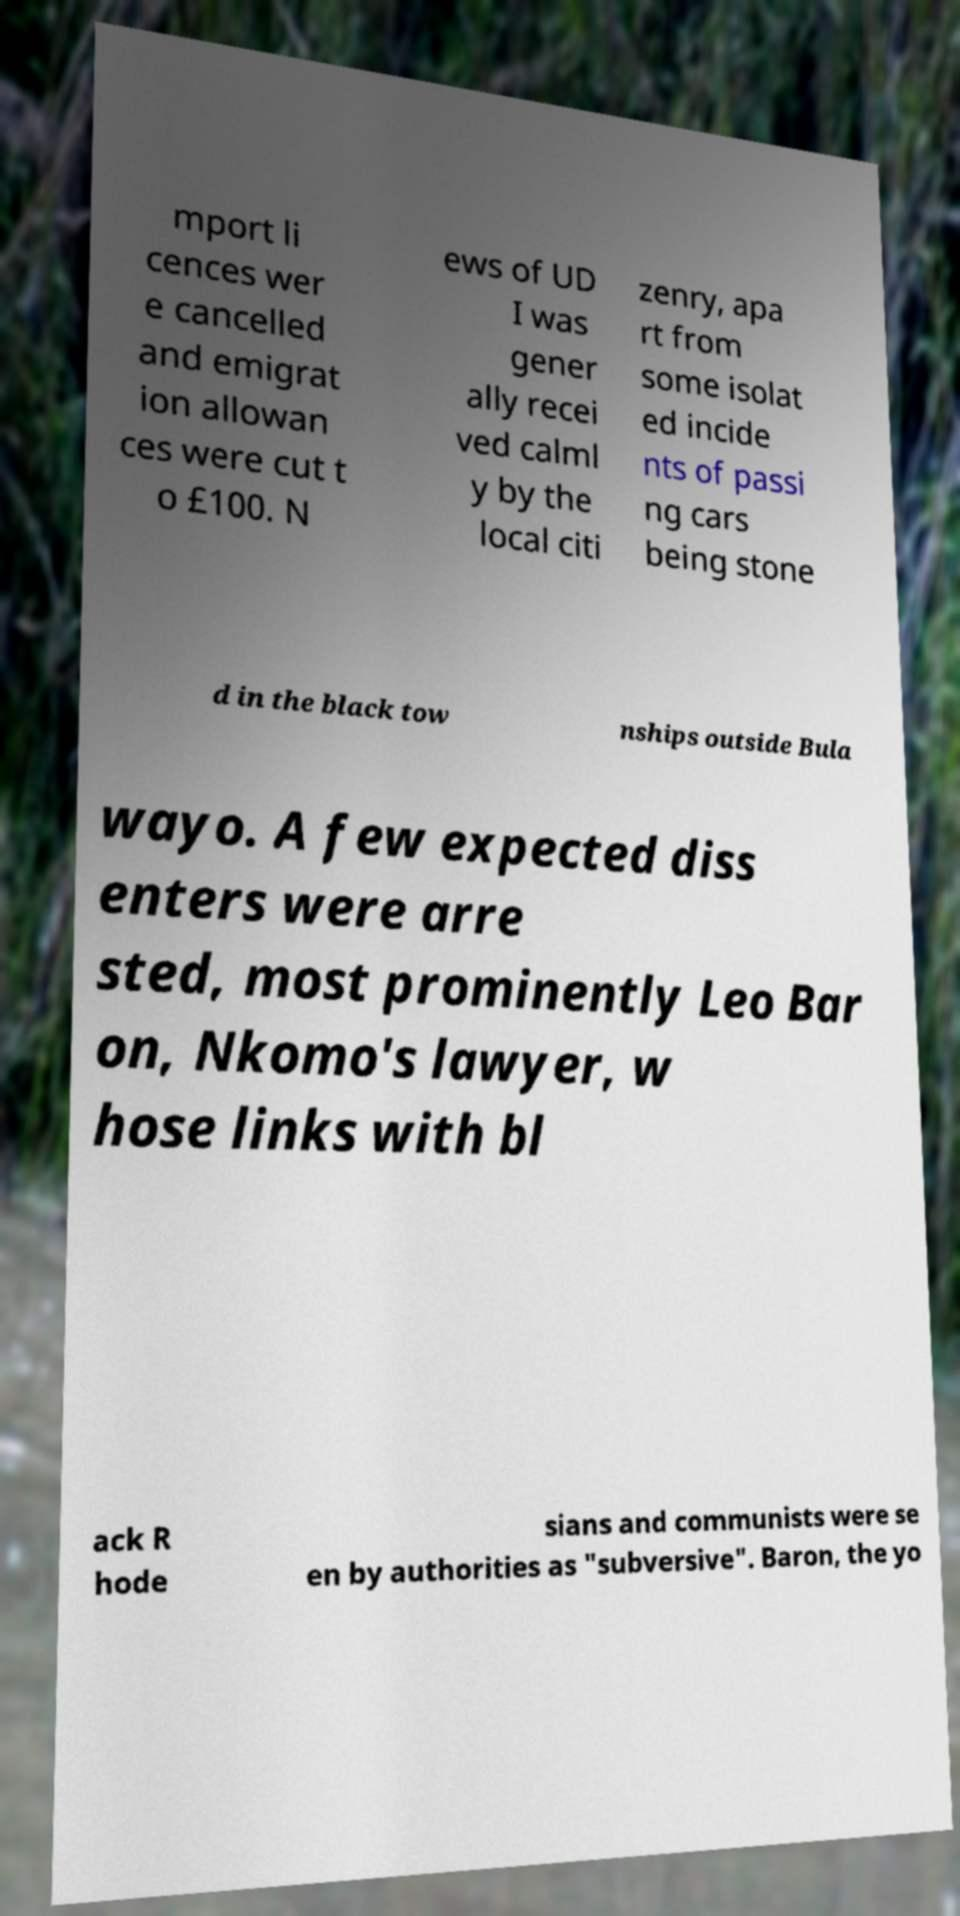Please identify and transcribe the text found in this image. mport li cences wer e cancelled and emigrat ion allowan ces were cut t o £100. N ews of UD I was gener ally recei ved calml y by the local citi zenry, apa rt from some isolat ed incide nts of passi ng cars being stone d in the black tow nships outside Bula wayo. A few expected diss enters were arre sted, most prominently Leo Bar on, Nkomo's lawyer, w hose links with bl ack R hode sians and communists were se en by authorities as "subversive". Baron, the yo 